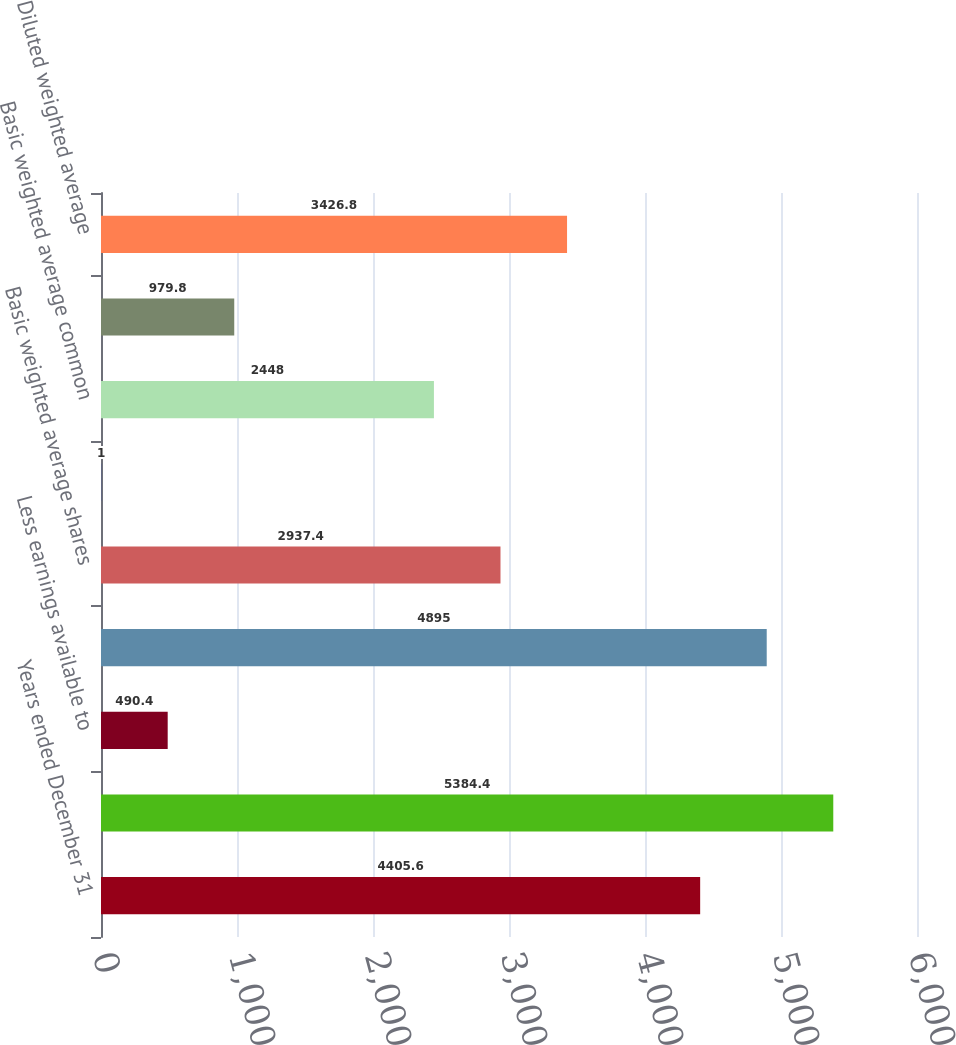Convert chart to OTSL. <chart><loc_0><loc_0><loc_500><loc_500><bar_chart><fcel>Years ended December 31<fcel>Net earnings<fcel>Less earnings available to<fcel>Net earnings available to<fcel>Basic weighted average shares<fcel>Less participating securities<fcel>Basic weighted average common<fcel>Dilutive potential common<fcel>Diluted weighted average<nl><fcel>4405.6<fcel>5384.4<fcel>490.4<fcel>4895<fcel>2937.4<fcel>1<fcel>2448<fcel>979.8<fcel>3426.8<nl></chart> 